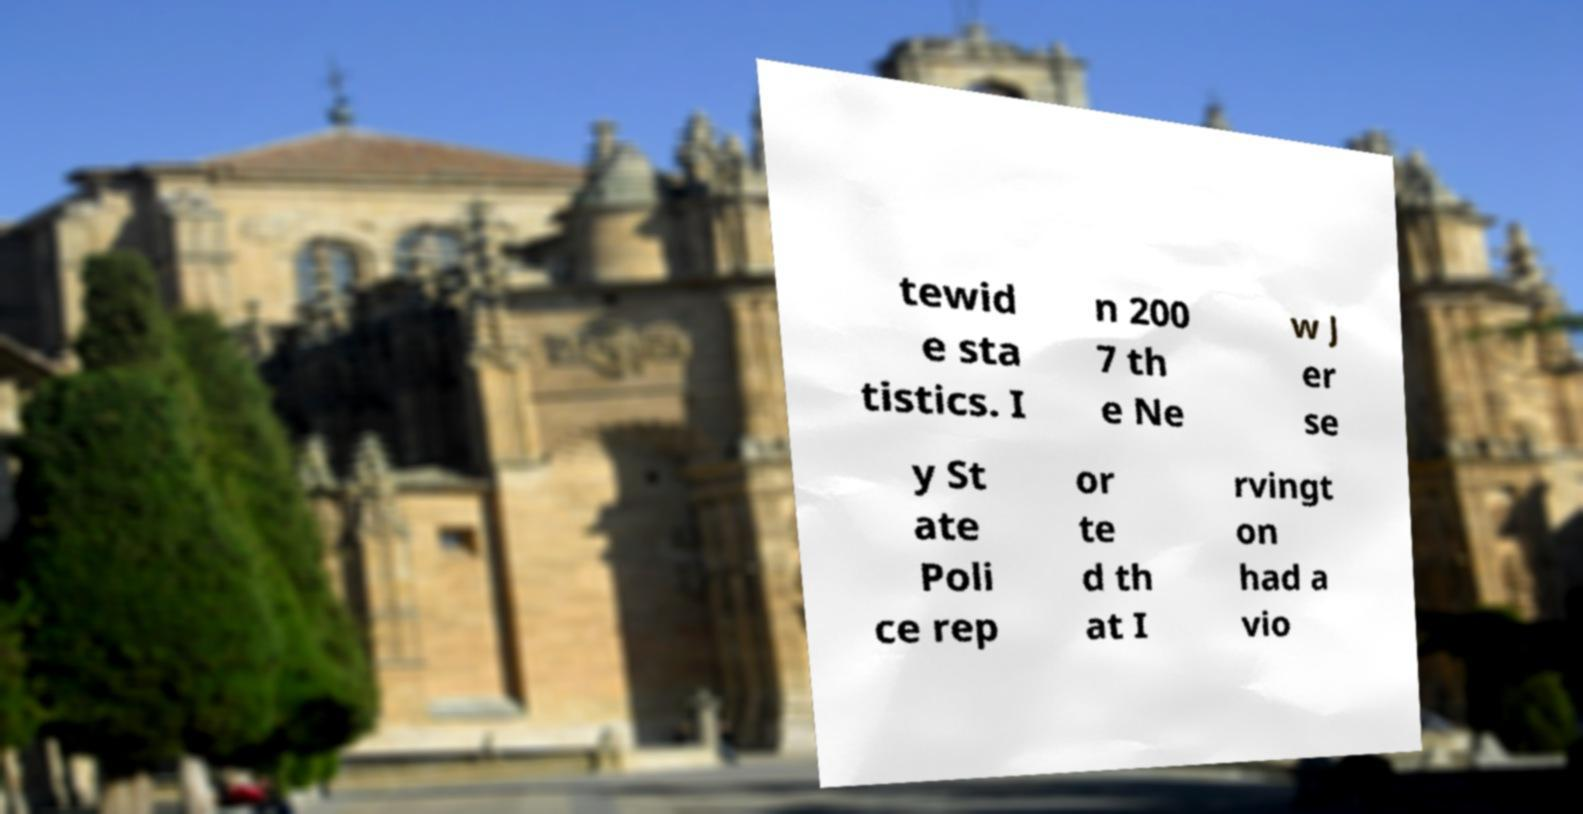I need the written content from this picture converted into text. Can you do that? tewid e sta tistics. I n 200 7 th e Ne w J er se y St ate Poli ce rep or te d th at I rvingt on had a vio 